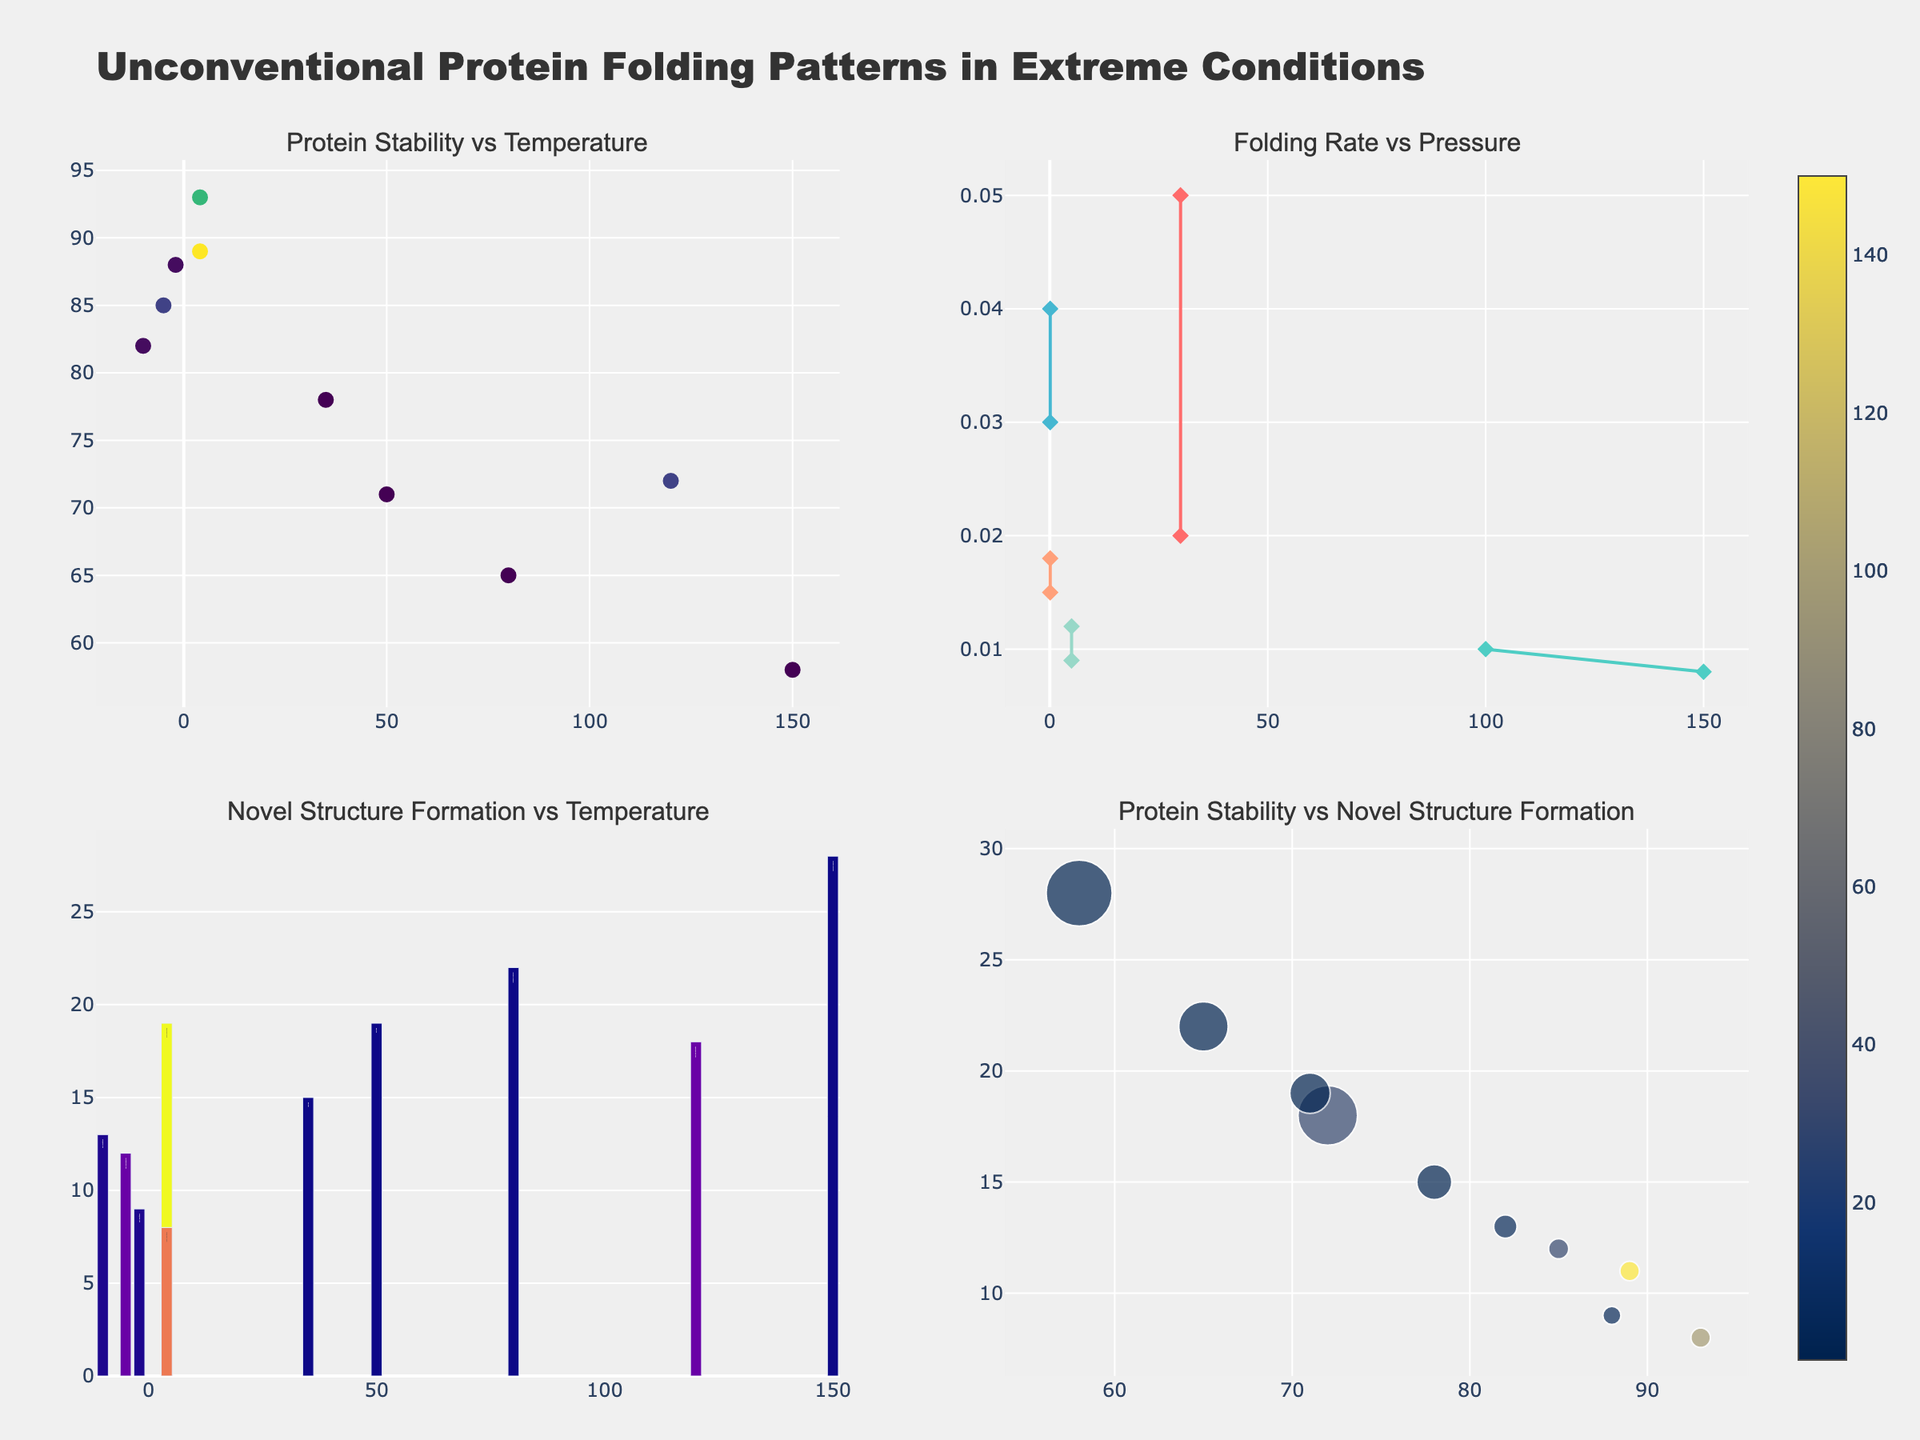What is the title of the figure? The title is usually located at the top of the figure. In this case, it is clearly mentioned in the layout update as "Unconventional Protein Folding Patterns in Extreme Conditions."
Answer: Unconventional Protein Folding Patterns in Extreme Conditions How many subplots are present in the figure? By examining the structure of the plots described, it is clear that there are four subplots. Each is assigned a specific relationship to be visualized, as described by the subplot titles.
Answer: 4 Which condition is associated with the highest protein stability at a temperature of 4°C and what is the stability percentage? By referring to the scatter plot in subplot 1, we can see that at a temperature of 4°C, Deep Sea Trench has the highest protein stability percentage of 93%.
Answer: Deep Sea Trench, 93% Which condition has the highest Folding Rate, and what is that rate? On observing the line plot in subplot 2, the condition with the highest peak along the Y-axis (Folding Rate) is Volcanic Fumarole which has a rate of 0.04 s^-1.
Answer: Volcanic Fumarole, 0.04 s^-1 In the bubble plot, which condition(s) exhibit(s) the lowest Novel Structure Formation at a Protein Stability of approximately 90%? In subplot 4, examining points near 90% along the X-axis, the Subglacial Lake condition exhibits the lowest Novel Structure Formation percentage of around 9%.
Answer: Subglacial Lake How does the Novel Structure Formation change with temperature for the Volcanic Fumarole condition, based on the bar plot? Observing the bars and associated temperatures in subplot 3 for Volcanic Fumarole, as the temperature increases from 80°C to 150°C, Novel Structure Formation increases from 22% to 28%.
Answer: Increases Which condition shows improvement in protein stability as temperature decreases from -2°C to -10°C? By analyzing the scatter plot in subplot 1 focusing on data points moving left from -2°C to -10°C and checking the Protein Stability percentages, Subglacial Lake shows improvement with stability increasing from 82% to 88%.
Answer: Subglacial Lake At a pressure of 150 MPa, how do Novel Structure Formation percentages compare between Deep Sea Trench conditions? Set focus on subplot 3 where Deep Sea Trench data points are compared along the bar heights; they show 8% (at 100 MPa) and 11% (at 150 MPa).
Answer: 11% is higher than 8% Overall, how does Protein Stability change with Pressure, as observed in the scatter plot? Evaluating the markers' color intensity in subplot 1, it shows that higher pressures (darker colors) tend to have higher protein stability percentages. This pattern is especially noticeable in Deep Sea Trench conditions.
Answer: Increases with Pressure 